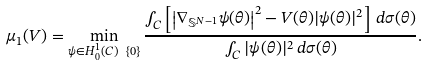Convert formula to latex. <formula><loc_0><loc_0><loc_500><loc_500>\mu _ { 1 } ( V ) = \min _ { \psi \in H ^ { 1 } _ { 0 } ( C ) \ \{ 0 \} } \frac { \int _ { C } \left [ \left | \nabla _ { \mathbb { S } ^ { N - 1 } } \psi ( \theta ) \right | ^ { 2 } - V ( \theta ) | \psi ( \theta ) | ^ { 2 } \right ] \, d \sigma ( \theta ) } { \int _ { C } | \psi ( \theta ) | ^ { 2 } \, d \sigma ( \theta ) } .</formula> 